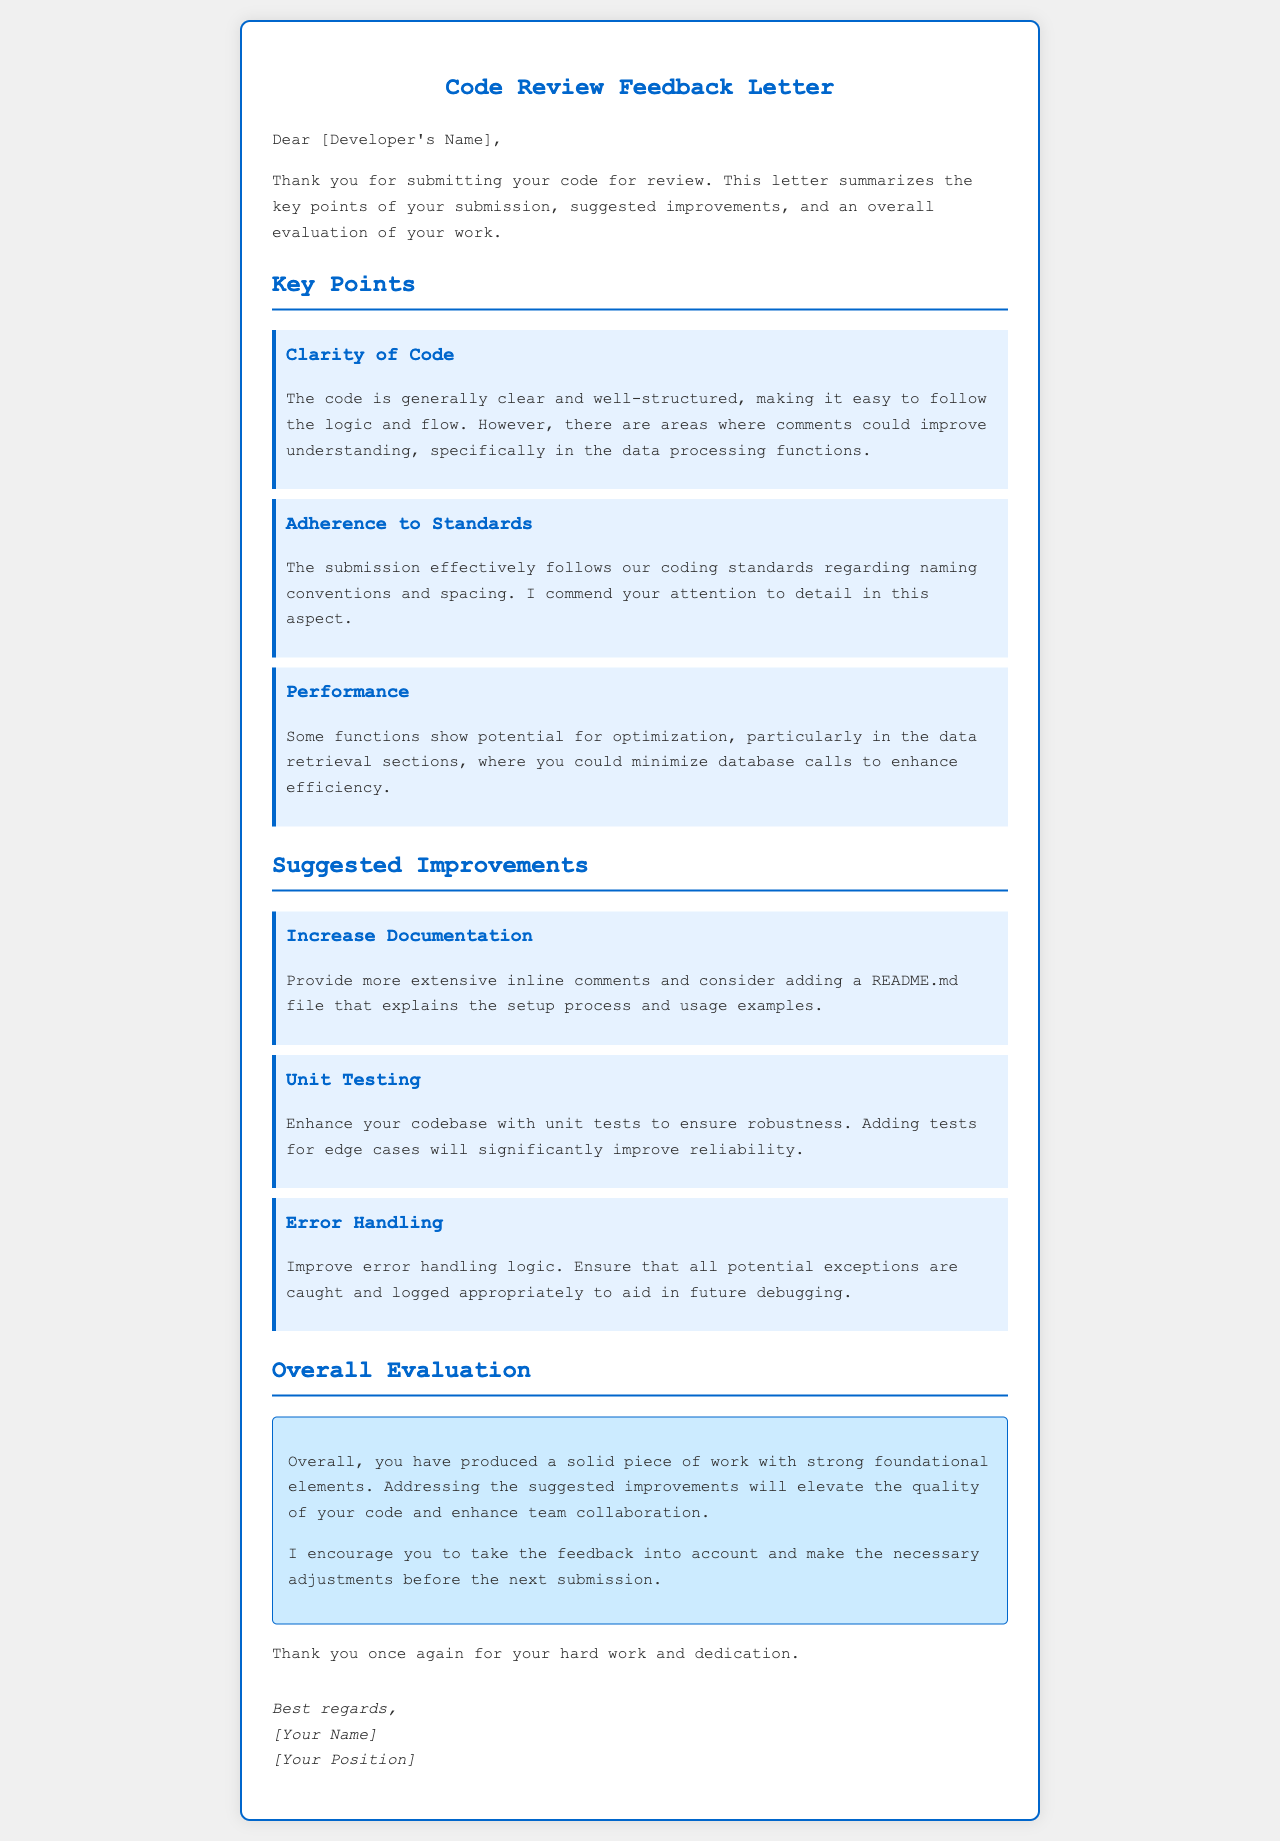What is the title of the letter? The title of the letter is located at the top of the document, clearly stating its purpose.
Answer: Code Review Feedback Letter Who is the letter addressed to? The recipient's name is indicated early in the letter.
Answer: [Developer's Name] What key point praises adherence to coding standards? This point is focused on maintaining coding conventions and is explicitly mentioned under the key points section.
Answer: Adherence to Standards What suggested improvement concerns documentation? This improvement specifically focuses on the need for more extensive documentation.
Answer: Increase Documentation How many key points are summarized in the letter? By counting the key points section, we can determine the number of topics discussed there.
Answer: Three What is mentioned as a potential optimization area? This section refers to specific functions that could be made more efficient.
Answer: Data retrieval sections What does the overall evaluation state about the produced work? The summary indicates the general quality of the code and encourages addressing suggested improvements.
Answer: Solid piece of work Which aspect of the code is recommended to enhance for robustness? This suggestion emphasizes the importance of testing the code.
Answer: Unit Testing What is one aspect highlighted for improving error handling? This identifies the necessity to manage exceptions more effectively.
Answer: Potential exceptions 